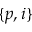<formula> <loc_0><loc_0><loc_500><loc_500>\{ p , i \}</formula> 